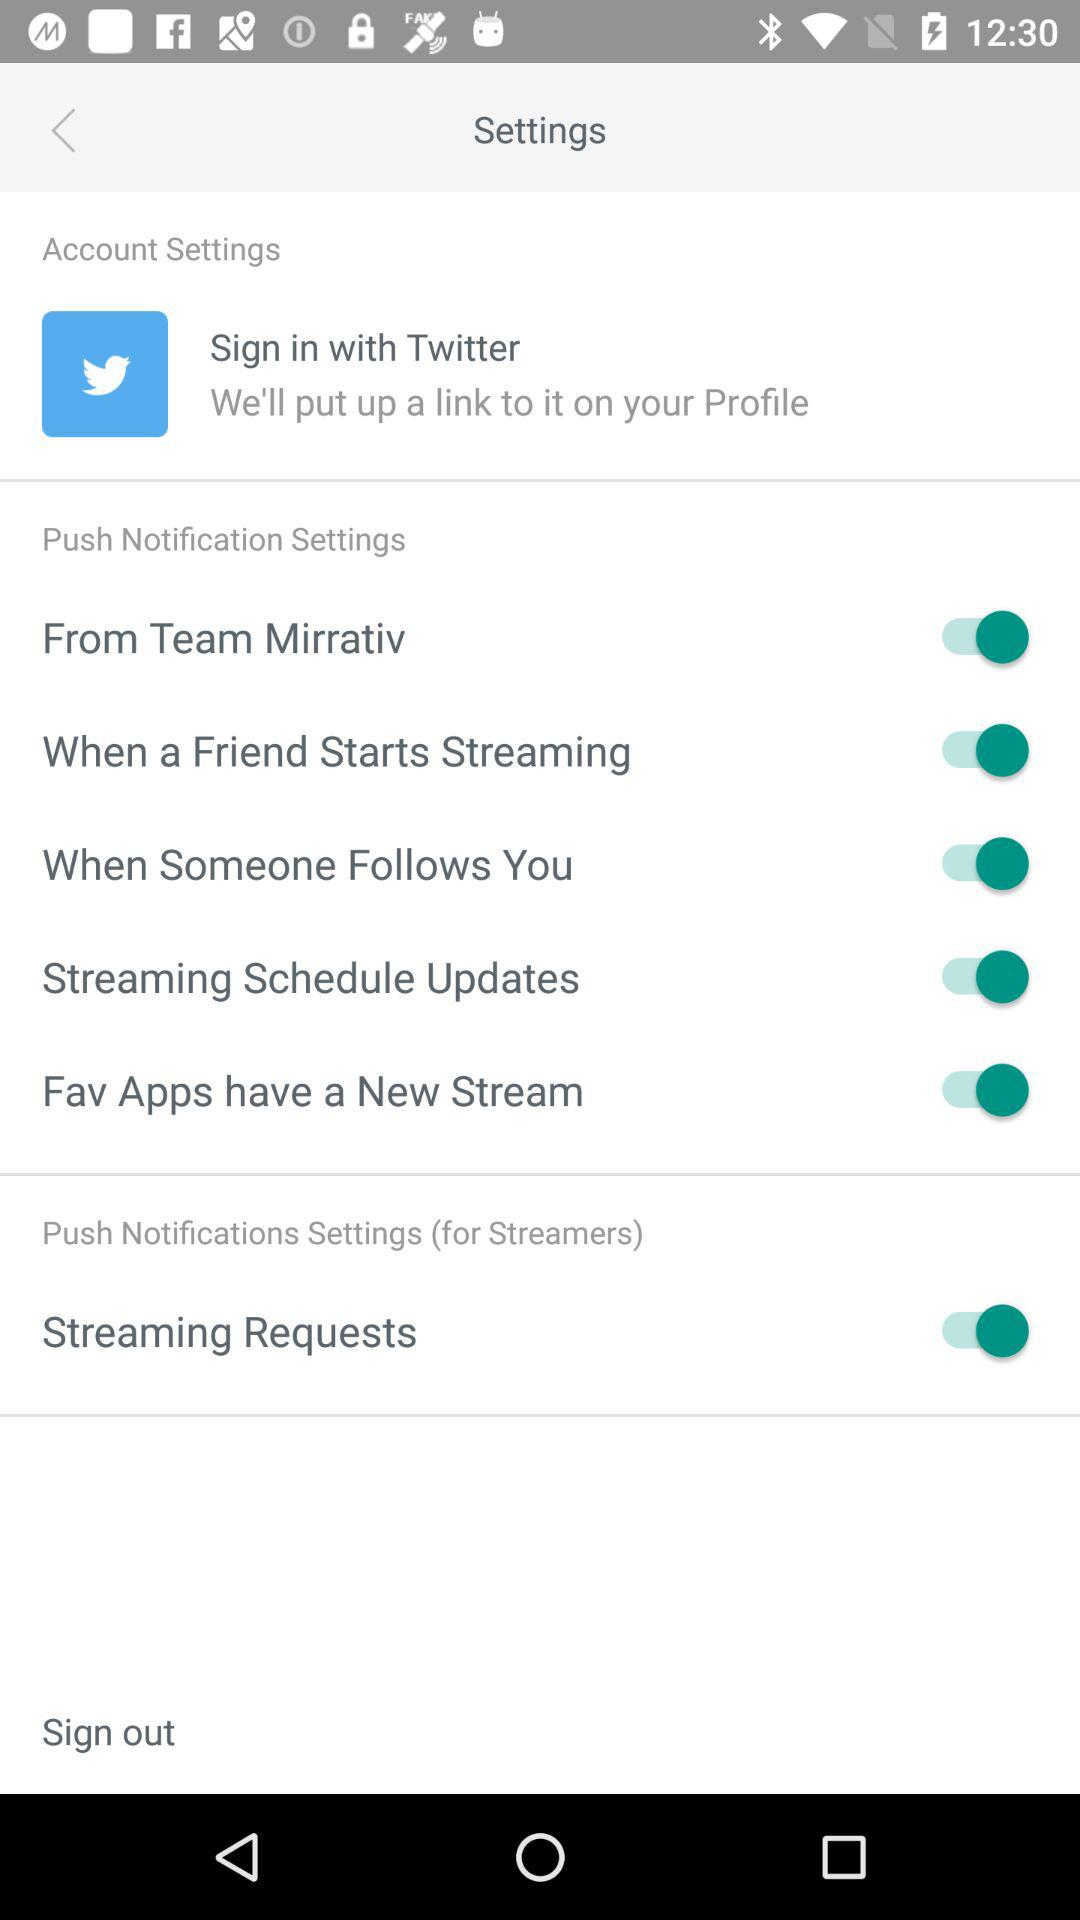What application can we use to sign in? You can use "Twitter" to sign in. 